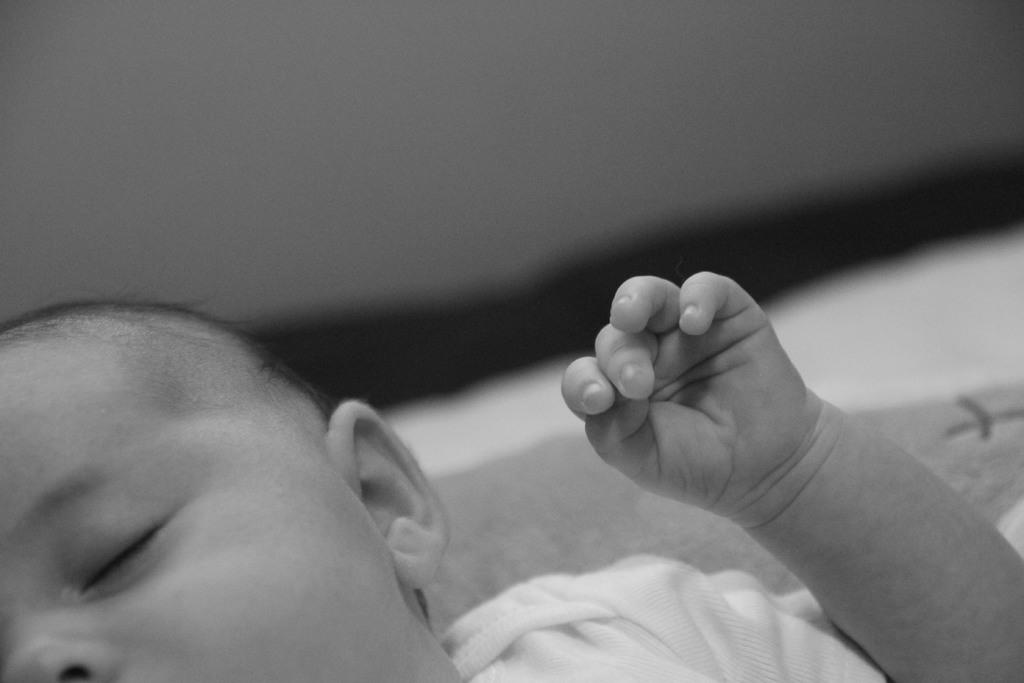What is the main subject of the image? There is a baby in the image. Where is the baby located? The baby is lying on a bed. What can be seen in the background of the image? There is a wall visible in the image. What type of zephyr can be seen blowing the baby's hair in the image? There is no zephyr present in the image, and the baby's hair is not being blown by any wind. Is the baby driving a car in the image? No, the baby is lying on a bed, not driving a car. 